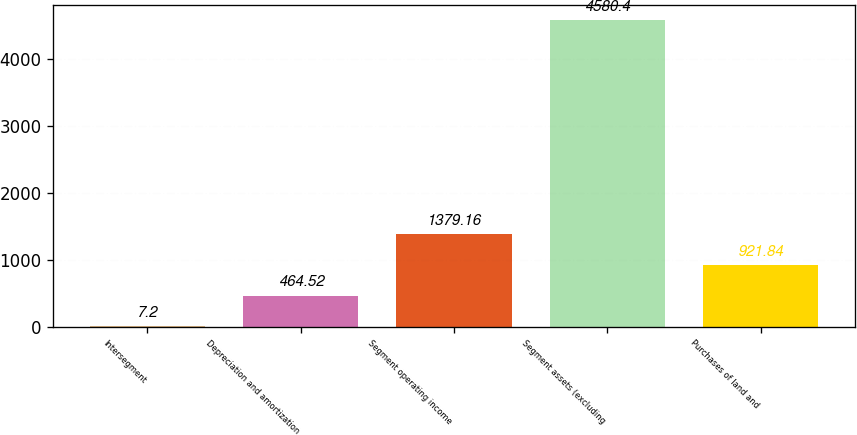Convert chart to OTSL. <chart><loc_0><loc_0><loc_500><loc_500><bar_chart><fcel>Intersegment<fcel>Depreciation and amortization<fcel>Segment operating income<fcel>Segment assets (excluding<fcel>Purchases of land and<nl><fcel>7.2<fcel>464.52<fcel>1379.16<fcel>4580.4<fcel>921.84<nl></chart> 